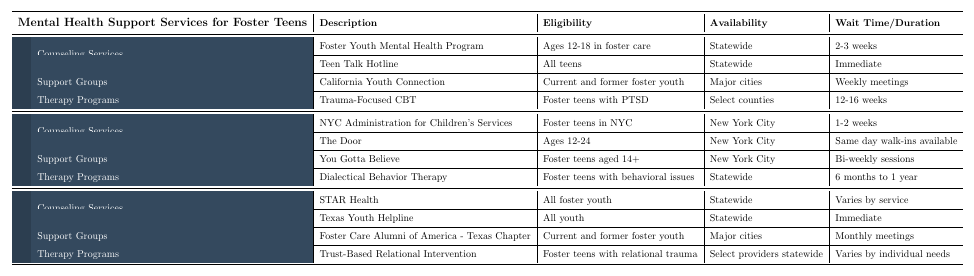What mental health program is available for foster teens in California that specializes in counseling? The table shows that the "Foster Youth Mental Health Program" provides specialized counseling for foster teens in California.
Answer: Foster Youth Mental Health Program How long is the wait time for the Teen Talk Hotline in California? According to the table, the availability for the Teen Talk Hotline is immediate, meaning there is no wait time.
Answer: Immediate Which state offers a crisis intervention hotline? The table indicates that Texas offers the "Texas Youth Helpline" for crisis intervention and referrals.
Answer: Texas What is the frequency of the peer support group in California? The California Youth Connection support group has weekly meetings as stated in the table.
Answer: Weekly meetings Which therapy program in New York is specifically for foster teens with behavioral issues? The "Dialectical Behavior Therapy" is the therapy program in New York for foster teens with behavioral issues as mentioned in the table.
Answer: Dialectical Behavior Therapy Which state's support group meets bi-weekly and is aimed at foster teens aged 14 and up? The "You Gotta Believe" support group in New York meets bi-weekly and is aimed at foster teens aged 14 and older.
Answer: New York How many weeks is the duration of the Trauma-Focused CBT program in California? The table states that the duration for the Trauma-Focused CBT program is between 12 to 16 weeks.
Answer: 12-16 weeks Are there any mental health services available for all foster youth in Texas? Yes, the "STAR Health" service offers comprehensive mental health services for all foster youth in Texas.
Answer: Yes Which program has the longest wait time in California? The wait time for the "Foster Youth Mental Health Program" is between 2 to 3 weeks, which is longer than the other programs listed.
Answer: 2-3 weeks If a foster teen is in NYC, which counseling service can they access with minimal wait time? The "The Door" offers same day walk-ins, providing access with minimal wait time for foster teens in NYC.
Answer: The Door 